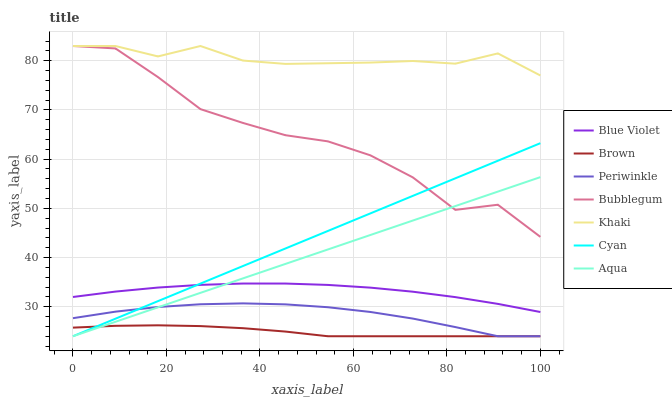Does Brown have the minimum area under the curve?
Answer yes or no. Yes. Does Khaki have the maximum area under the curve?
Answer yes or no. Yes. Does Aqua have the minimum area under the curve?
Answer yes or no. No. Does Aqua have the maximum area under the curve?
Answer yes or no. No. Is Cyan the smoothest?
Answer yes or no. Yes. Is Bubblegum the roughest?
Answer yes or no. Yes. Is Khaki the smoothest?
Answer yes or no. No. Is Khaki the roughest?
Answer yes or no. No. Does Brown have the lowest value?
Answer yes or no. Yes. Does Khaki have the lowest value?
Answer yes or no. No. Does Bubblegum have the highest value?
Answer yes or no. Yes. Does Aqua have the highest value?
Answer yes or no. No. Is Periwinkle less than Khaki?
Answer yes or no. Yes. Is Khaki greater than Periwinkle?
Answer yes or no. Yes. Does Bubblegum intersect Aqua?
Answer yes or no. Yes. Is Bubblegum less than Aqua?
Answer yes or no. No. Is Bubblegum greater than Aqua?
Answer yes or no. No. Does Periwinkle intersect Khaki?
Answer yes or no. No. 